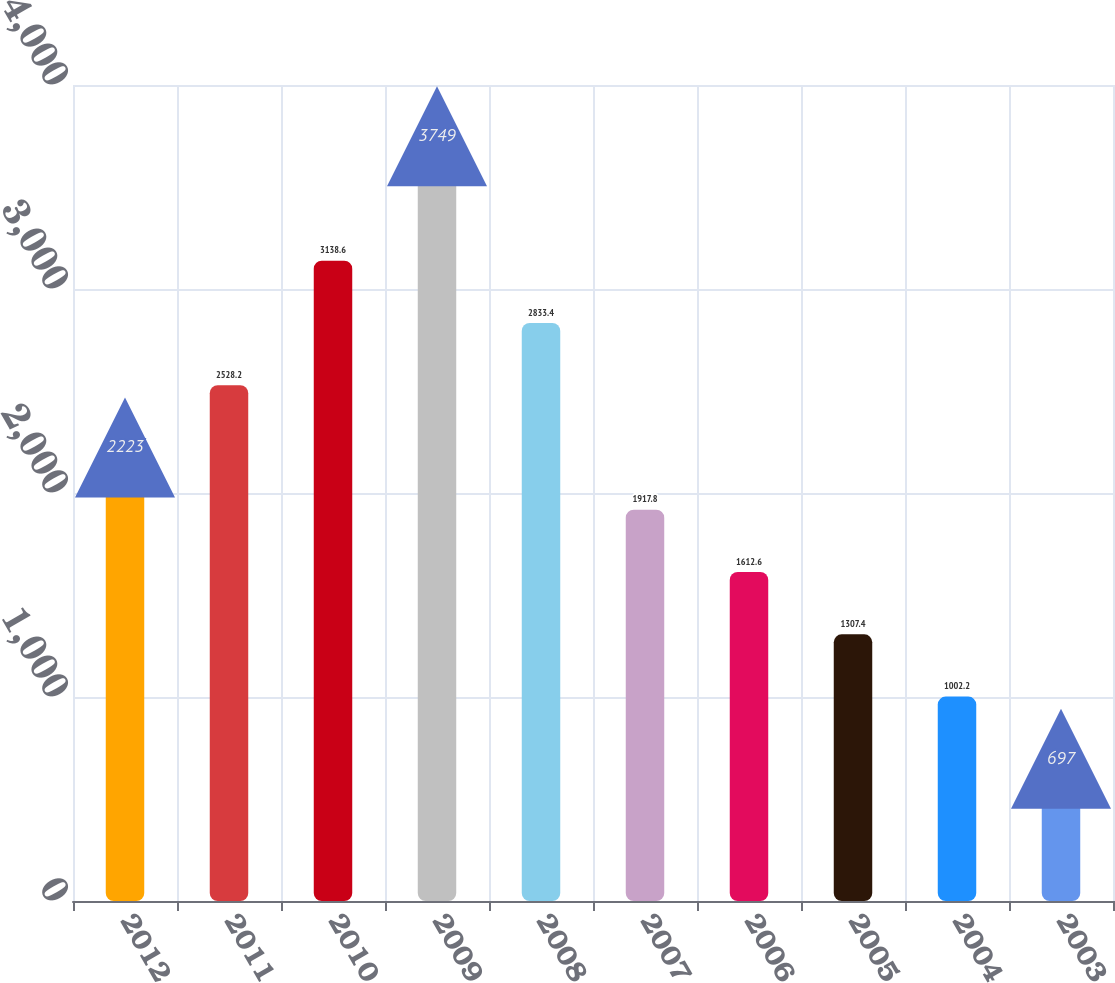<chart> <loc_0><loc_0><loc_500><loc_500><bar_chart><fcel>2012<fcel>2011<fcel>2010<fcel>2009<fcel>2008<fcel>2007<fcel>2006<fcel>2005<fcel>2004<fcel>2003<nl><fcel>2223<fcel>2528.2<fcel>3138.6<fcel>3749<fcel>2833.4<fcel>1917.8<fcel>1612.6<fcel>1307.4<fcel>1002.2<fcel>697<nl></chart> 